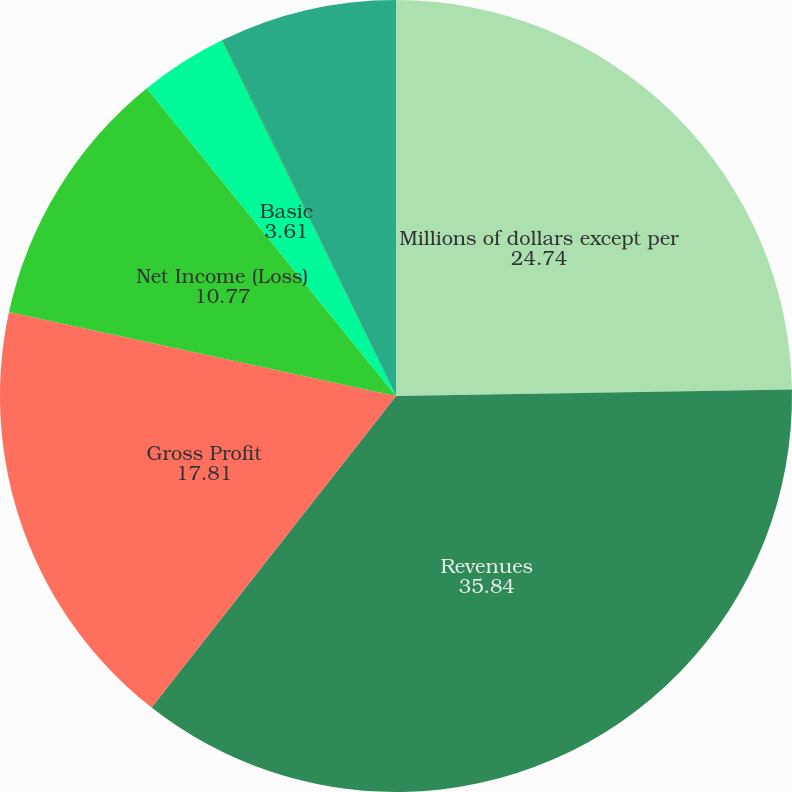Convert chart to OTSL. <chart><loc_0><loc_0><loc_500><loc_500><pie_chart><fcel>Millions of dollars except per<fcel>Revenues<fcel>Gross Profit<fcel>Net Income (Loss)<fcel>Basic<fcel>Diluted<fcel>Net Income<nl><fcel>24.74%<fcel>35.84%<fcel>17.81%<fcel>10.77%<fcel>3.61%<fcel>0.03%<fcel>7.19%<nl></chart> 